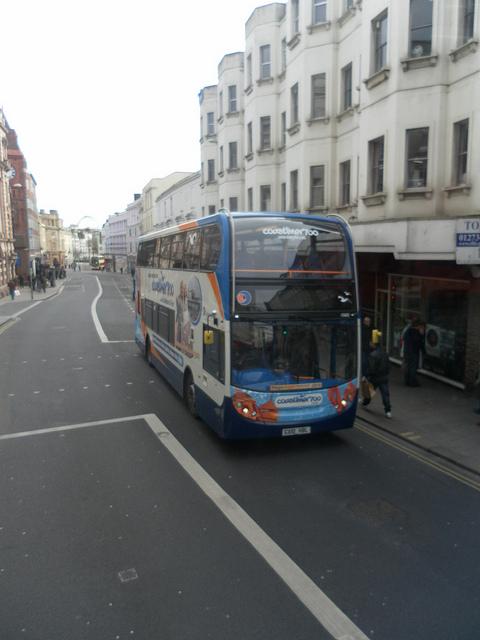How many buses are on the street?
Be succinct. 1. Who own's the picture?
Concise answer only. Photographer. What color is the front of the bus?
Give a very brief answer. Blue. Is this a rural or urban scene?
Answer briefly. Urban. How many stories does the bus have?q?
Quick response, please. 2. What is the number displayed in lights on the bus?
Give a very brief answer. 700. 